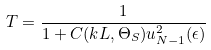<formula> <loc_0><loc_0><loc_500><loc_500>T = \frac { 1 } { 1 + C ( k L , \Theta _ { S } ) u ^ { 2 } _ { N - 1 } ( \epsilon ) }</formula> 